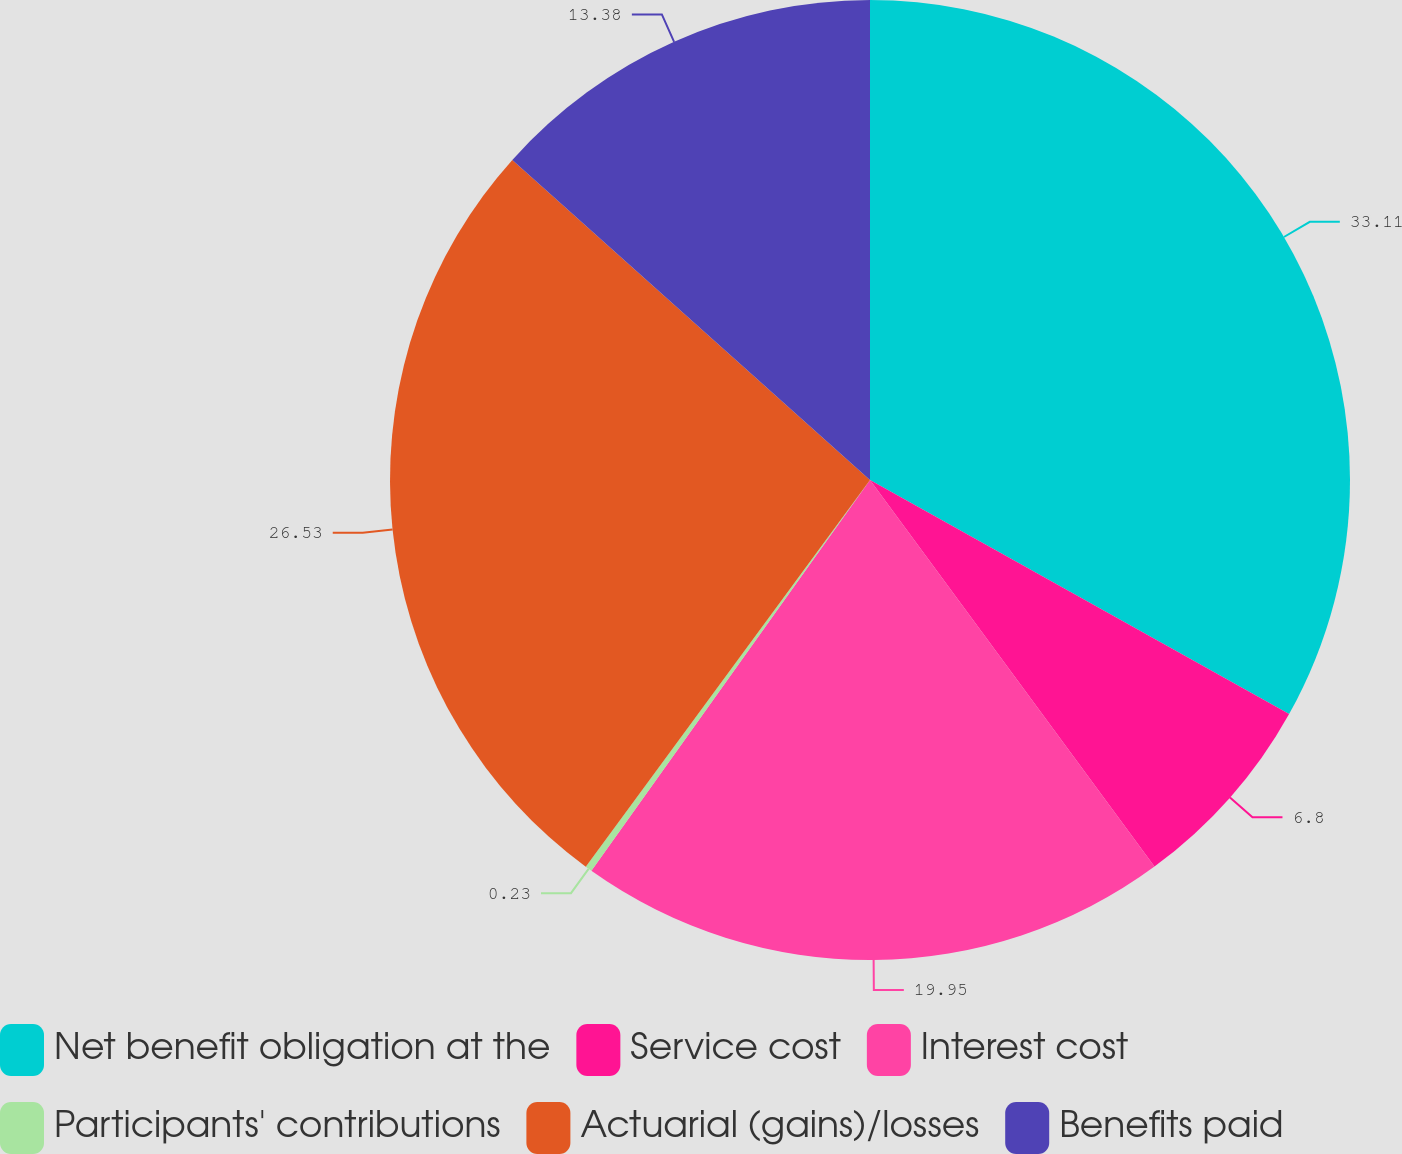Convert chart to OTSL. <chart><loc_0><loc_0><loc_500><loc_500><pie_chart><fcel>Net benefit obligation at the<fcel>Service cost<fcel>Interest cost<fcel>Participants' contributions<fcel>Actuarial (gains)/losses<fcel>Benefits paid<nl><fcel>33.1%<fcel>6.8%<fcel>19.95%<fcel>0.23%<fcel>26.53%<fcel>13.38%<nl></chart> 